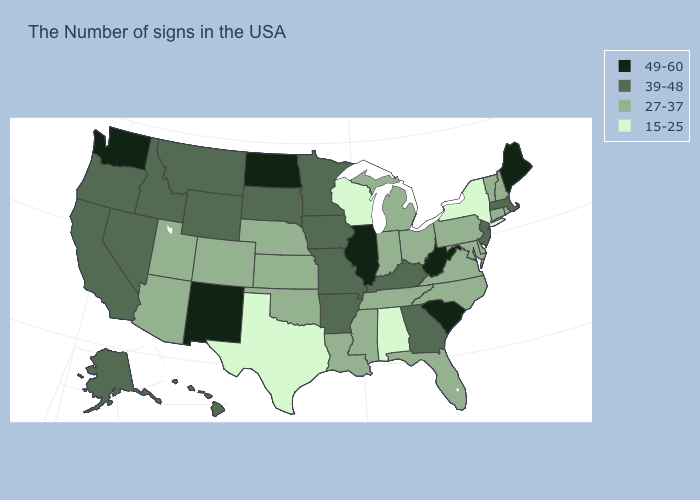What is the value of Nevada?
Give a very brief answer. 39-48. What is the value of Alaska?
Give a very brief answer. 39-48. What is the value of Washington?
Keep it brief. 49-60. What is the lowest value in states that border North Carolina?
Keep it brief. 27-37. Name the states that have a value in the range 49-60?
Be succinct. Maine, South Carolina, West Virginia, Illinois, North Dakota, New Mexico, Washington. Which states hav the highest value in the MidWest?
Short answer required. Illinois, North Dakota. Among the states that border Indiana , which have the lowest value?
Give a very brief answer. Ohio, Michigan. What is the highest value in states that border North Carolina?
Answer briefly. 49-60. Is the legend a continuous bar?
Give a very brief answer. No. What is the value of Ohio?
Quick response, please. 27-37. Among the states that border North Dakota , which have the lowest value?
Write a very short answer. Minnesota, South Dakota, Montana. What is the lowest value in states that border Arkansas?
Keep it brief. 15-25. Name the states that have a value in the range 39-48?
Answer briefly. Massachusetts, New Jersey, Georgia, Kentucky, Missouri, Arkansas, Minnesota, Iowa, South Dakota, Wyoming, Montana, Idaho, Nevada, California, Oregon, Alaska, Hawaii. What is the value of Washington?
Answer briefly. 49-60. What is the value of Louisiana?
Quick response, please. 27-37. 